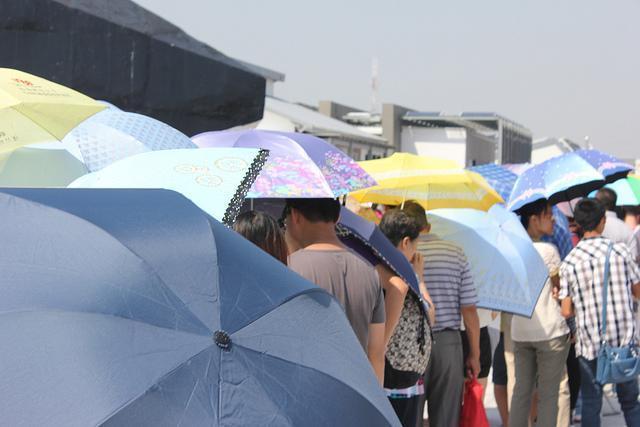How many umbrellas are visible?
Give a very brief answer. 8. How many people can be seen?
Give a very brief answer. 6. How many cars long is the train?
Give a very brief answer. 0. 